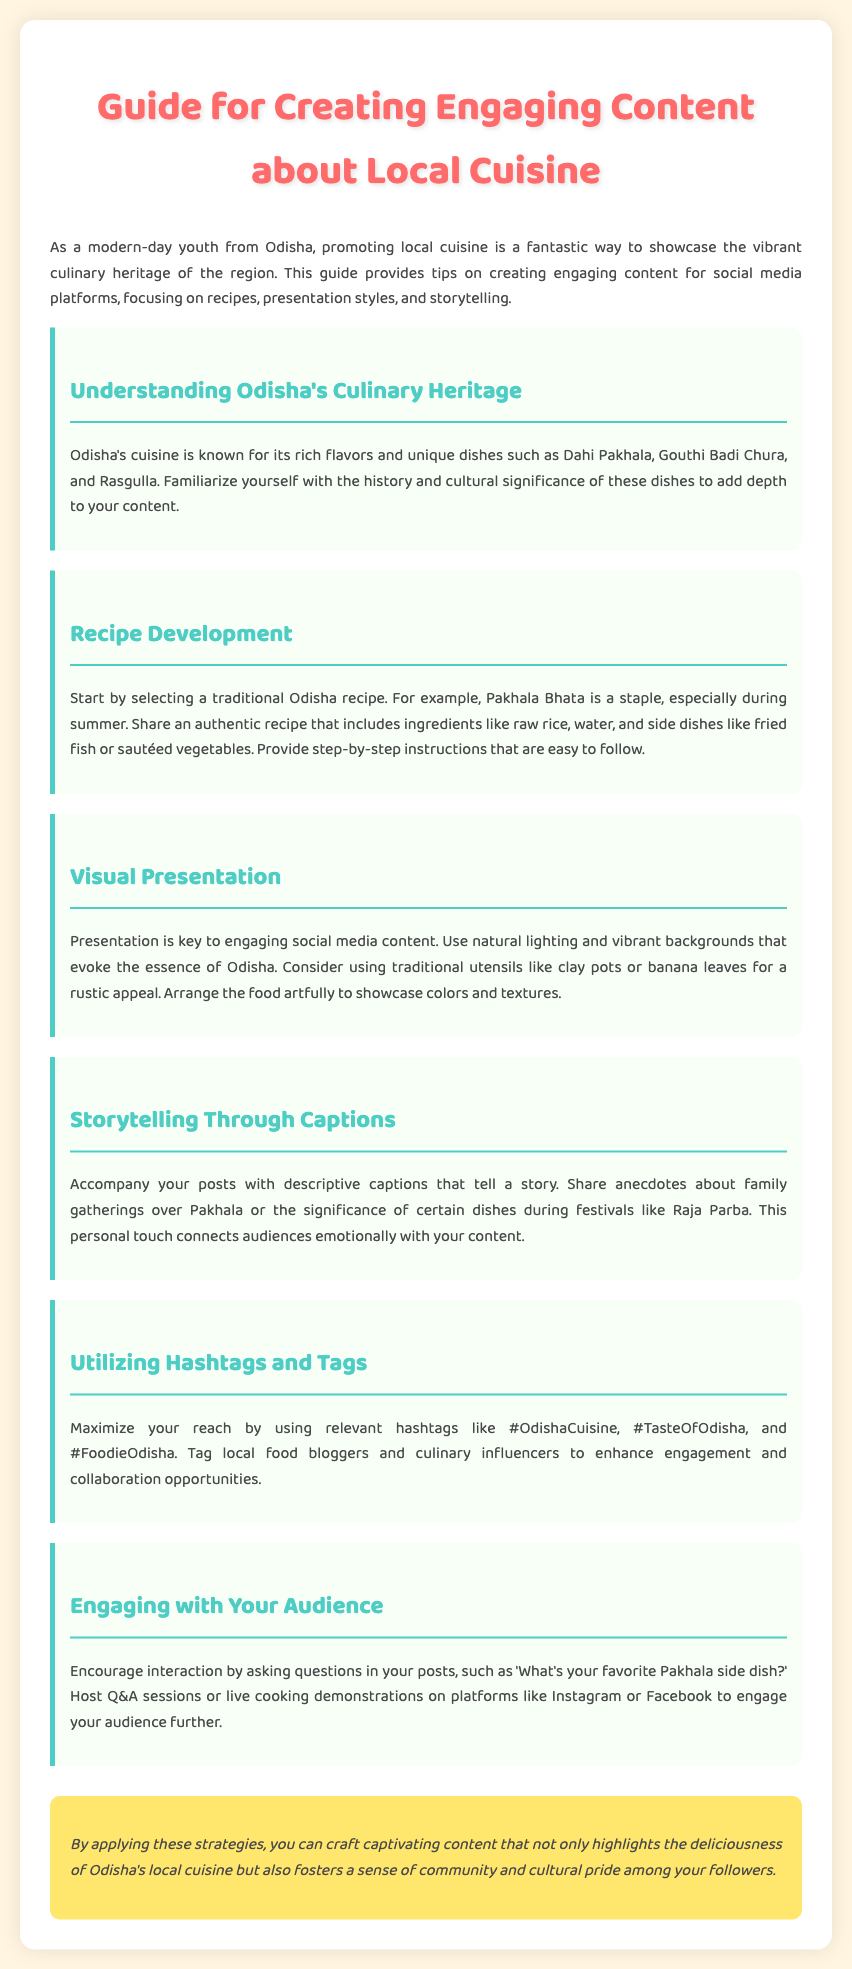What is the title of the document? The title is clearly stated at the beginning of the document as "Guide for Creating Engaging Content about Local Cuisine."
Answer: Guide for Creating Engaging Content about Local Cuisine What are two traditional dishes mentioned in the guide? The guide highlights specific traditional items under "Understanding Odisha's Culinary Heritage," mentioning Dahi Pakhala and Gouthi Badi Chura.
Answer: Dahi Pakhala, Gouthi Badi Chura What is a staple dish in Odisha mentioned for the recipe development? The document specifies that Pakhala Bhata is a staple dish highlighted under "Recipe Development."
Answer: Pakhala Bhata Which utensils are suggested for a rustic appeal in food presentation? The guide recommends using traditional utensils like clay pots or banana leaves for presenting food visually.
Answer: Clay pots, banana leaves What encourages audience interaction according to the guide? The section "Engaging with Your Audience" discusses the importance of asking questions in posts to foster interaction.
Answer: Asking questions How many sections are there in the guide? By counting the distinct content sections, including the introduction and conclusion, it's clear that there are six main sections in the guide.
Answer: Six What year is the guide suitable for posting on social media? The guide is appropriate for current usage, reflecting modern trends among youth, particularly in 2023.
Answer: 2023 